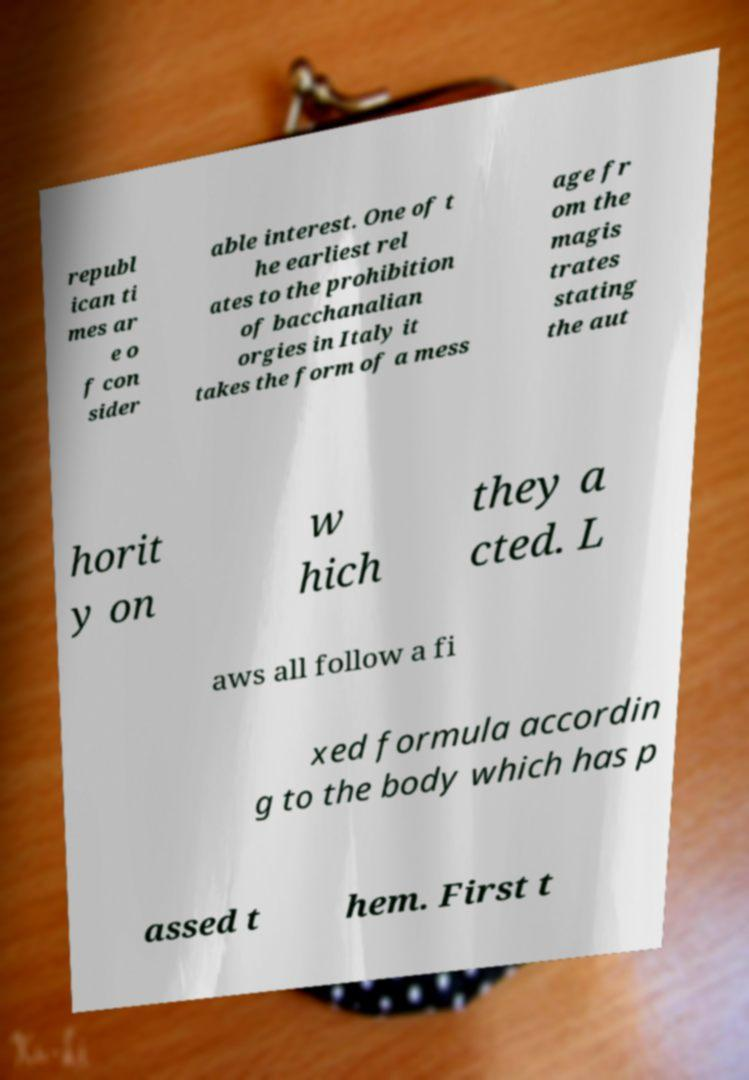Please identify and transcribe the text found in this image. republ ican ti mes ar e o f con sider able interest. One of t he earliest rel ates to the prohibition of bacchanalian orgies in Italy it takes the form of a mess age fr om the magis trates stating the aut horit y on w hich they a cted. L aws all follow a fi xed formula accordin g to the body which has p assed t hem. First t 